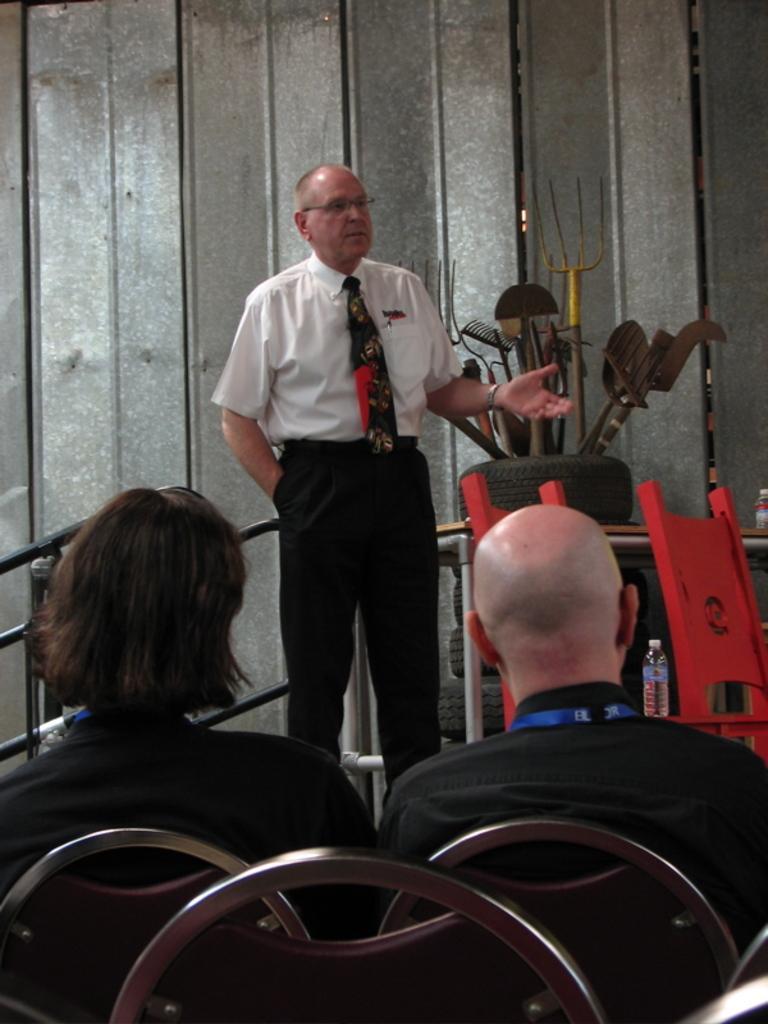Please provide a concise description of this image. In the image we can see a person standing, wearing clothes, tie and spectacles. There is a water bottle and many other things. We can see there are even two people, wearing clothes, they are sitting on the chair and there are many chairs. 